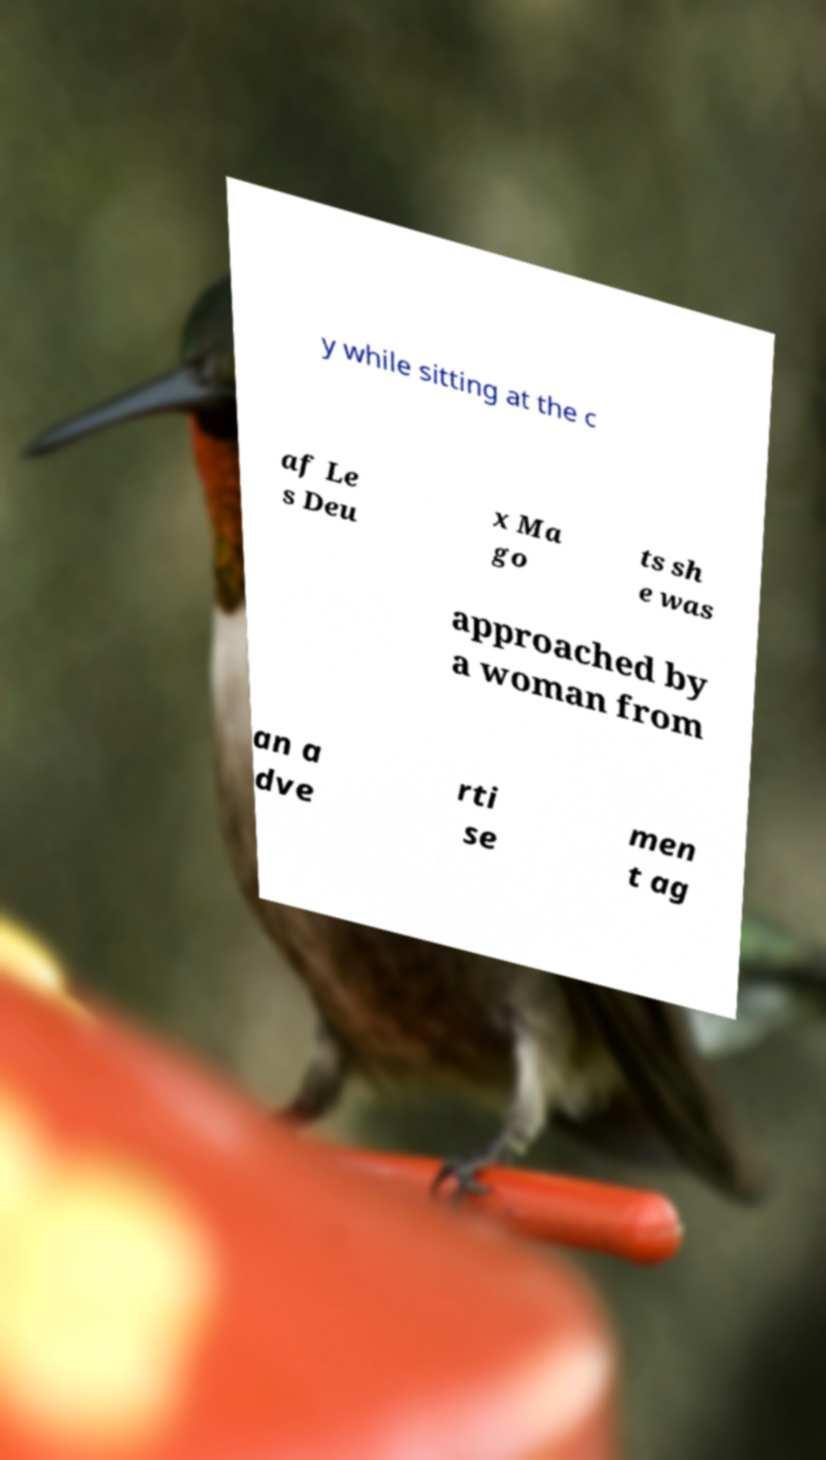Could you assist in decoding the text presented in this image and type it out clearly? y while sitting at the c af Le s Deu x Ma go ts sh e was approached by a woman from an a dve rti se men t ag 